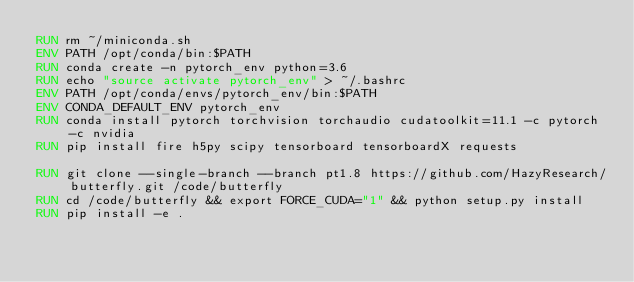<code> <loc_0><loc_0><loc_500><loc_500><_Dockerfile_>RUN rm ~/miniconda.sh
ENV PATH /opt/conda/bin:$PATH
RUN conda create -n pytorch_env python=3.6
RUN echo "source activate pytorch_env" > ~/.bashrc
ENV PATH /opt/conda/envs/pytorch_env/bin:$PATH
ENV CONDA_DEFAULT_ENV pytorch_env
RUN conda install pytorch torchvision torchaudio cudatoolkit=11.1 -c pytorch -c nvidia
RUN pip install fire h5py scipy tensorboard tensorboardX requests

RUN git clone --single-branch --branch pt1.8 https://github.com/HazyResearch/butterfly.git /code/butterfly
RUN cd /code/butterfly && export FORCE_CUDA="1" && python setup.py install
RUN pip install -e .
</code> 